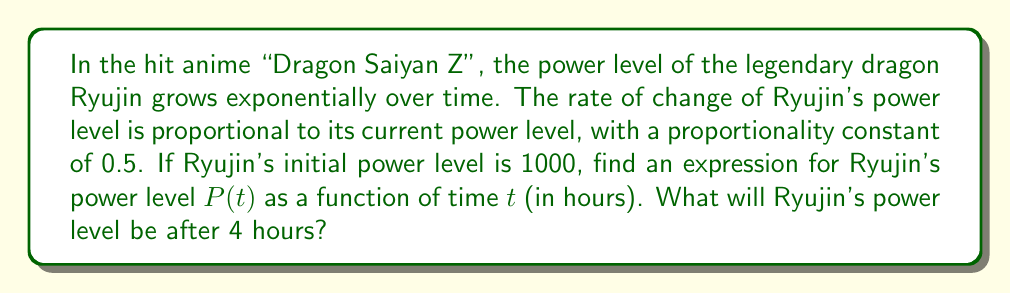Show me your answer to this math problem. Omg, this is so exciting! Let's power up and solve this differential equation step by step:

1) First, we need to set up our differential equation. Since the rate of change of power level is proportional to the current power level, we can write:

   $$\frac{dP}{dt} = kP$$

   where k is the proportionality constant, which is given as 0.5.

2) Substituting k = 0.5, we get:

   $$\frac{dP}{dt} = 0.5P$$

3) This is a separable differential equation. Let's separate the variables:

   $$\frac{dP}{P} = 0.5dt$$

4) Now, let's integrate both sides:

   $$\int \frac{dP}{P} = \int 0.5dt$$

5) This gives us:

   $$\ln|P| = 0.5t + C$$

   where C is the constant of integration.

6) Now, let's exponentiate both sides:

   $$P = e^{0.5t + C} = e^C \cdot e^{0.5t}$$

7) Let's call $e^C = A$, so our general solution is:

   $$P(t) = Ae^{0.5t}$$

8) To find A, we use the initial condition. We're told that the initial power level is 1000, so:

   $$1000 = Ae^{0.5(0)}$$
   $$1000 = A$$

9) Therefore, our specific solution is:

   $$P(t) = 1000e^{0.5t}$$

10) To find Ryujin's power level after 4 hours, we simply substitute t = 4:

    $$P(4) = 1000e^{0.5(4)} = 1000e^2 \approx 7389$$

Wow, Ryujin's power level is over 7000 after just 4 hours! That's some super saiyan level growth!
Answer: Ryujin's power level as a function of time is $P(t) = 1000e^{0.5t}$, where t is in hours. After 4 hours, Ryujin's power level will be approximately 7389. 